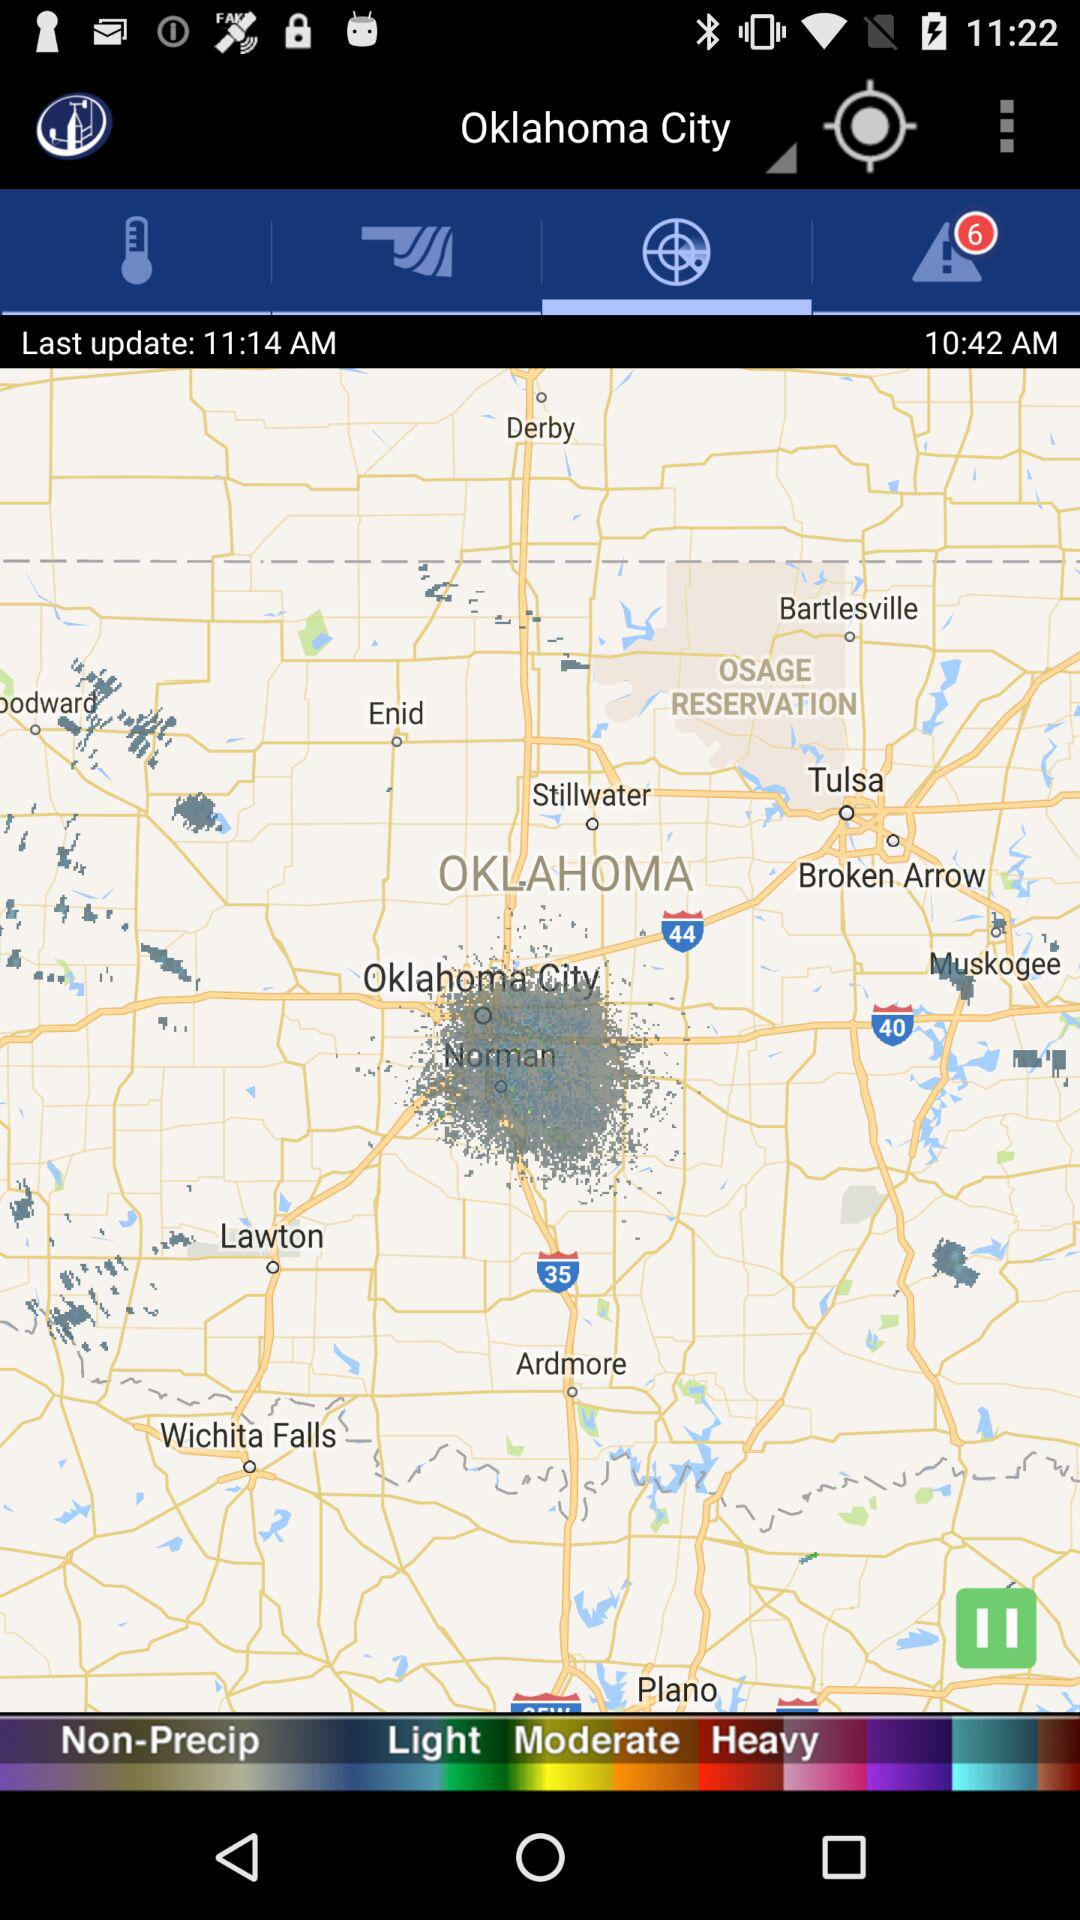What is the last updated time? The last updated time is 11:14 AM. 